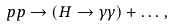Convert formula to latex. <formula><loc_0><loc_0><loc_500><loc_500>p p \rightarrow ( H \rightarrow \gamma \gamma ) + \dots \, ,</formula> 